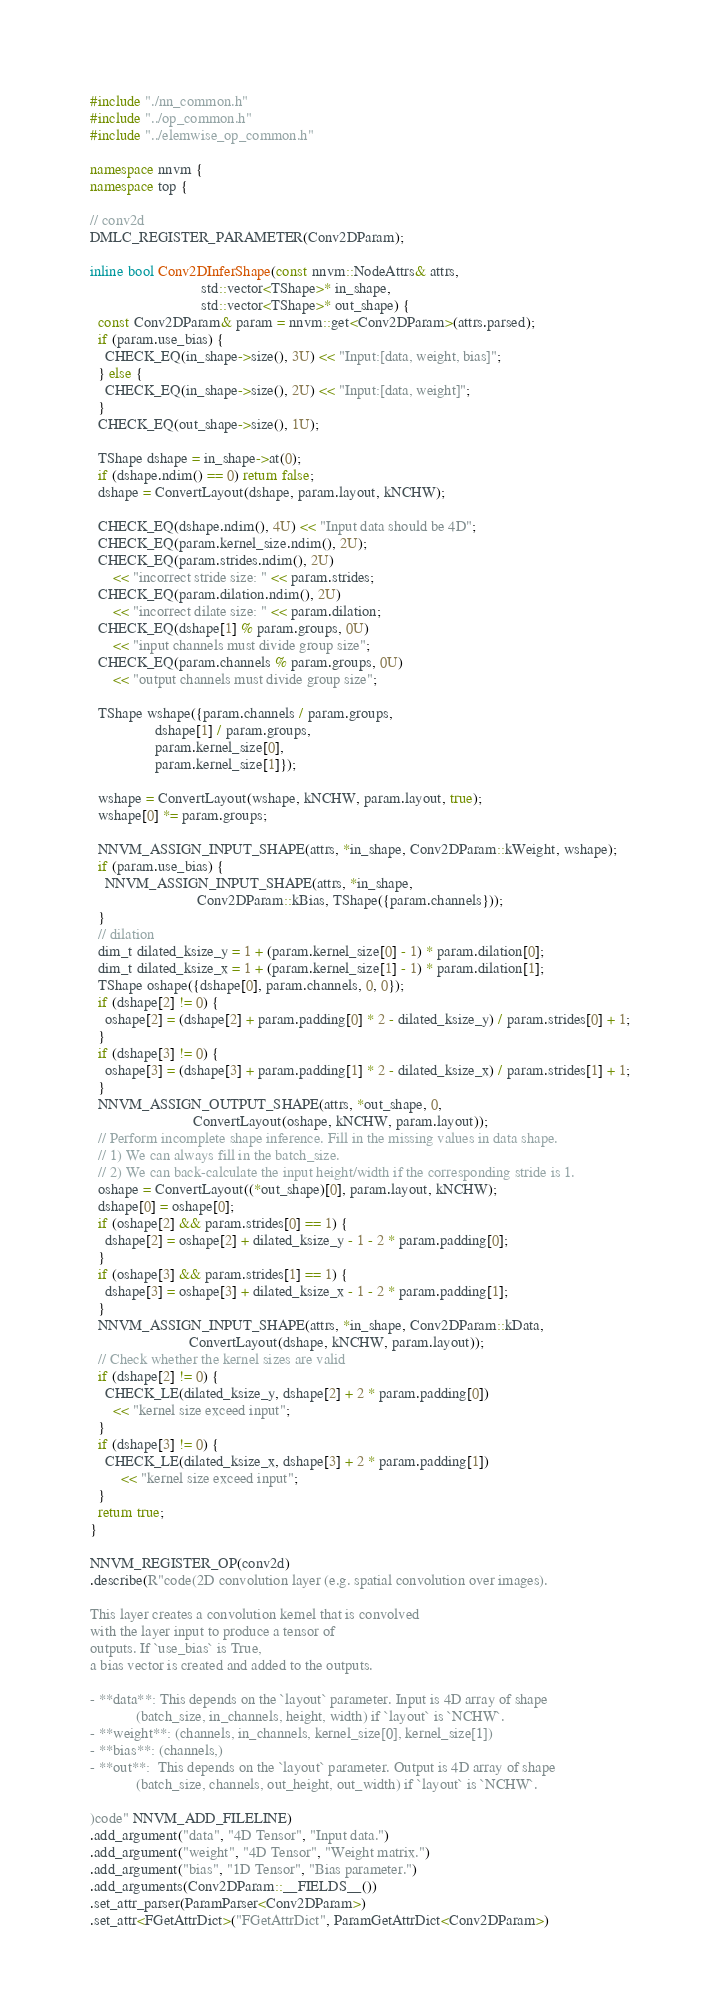Convert code to text. <code><loc_0><loc_0><loc_500><loc_500><_C++_>#include "./nn_common.h"
#include "../op_common.h"
#include "../elemwise_op_common.h"

namespace nnvm {
namespace top {

// conv2d
DMLC_REGISTER_PARAMETER(Conv2DParam);

inline bool Conv2DInferShape(const nnvm::NodeAttrs& attrs,
                             std::vector<TShape>* in_shape,
                             std::vector<TShape>* out_shape) {
  const Conv2DParam& param = nnvm::get<Conv2DParam>(attrs.parsed);
  if (param.use_bias) {
    CHECK_EQ(in_shape->size(), 3U) << "Input:[data, weight, bias]";
  } else {
    CHECK_EQ(in_shape->size(), 2U) << "Input:[data, weight]";
  }
  CHECK_EQ(out_shape->size(), 1U);

  TShape dshape = in_shape->at(0);
  if (dshape.ndim() == 0) return false;
  dshape = ConvertLayout(dshape, param.layout, kNCHW);

  CHECK_EQ(dshape.ndim(), 4U) << "Input data should be 4D";
  CHECK_EQ(param.kernel_size.ndim(), 2U);
  CHECK_EQ(param.strides.ndim(), 2U)
      << "incorrect stride size: " << param.strides;
  CHECK_EQ(param.dilation.ndim(), 2U)
      << "incorrect dilate size: " << param.dilation;
  CHECK_EQ(dshape[1] % param.groups, 0U)
      << "input channels must divide group size";
  CHECK_EQ(param.channels % param.groups, 0U)
      << "output channels must divide group size";

  TShape wshape({param.channels / param.groups,
                 dshape[1] / param.groups,
                 param.kernel_size[0],
                 param.kernel_size[1]});

  wshape = ConvertLayout(wshape, kNCHW, param.layout, true);
  wshape[0] *= param.groups;

  NNVM_ASSIGN_INPUT_SHAPE(attrs, *in_shape, Conv2DParam::kWeight, wshape);
  if (param.use_bias) {
    NNVM_ASSIGN_INPUT_SHAPE(attrs, *in_shape,
                            Conv2DParam::kBias, TShape({param.channels}));
  }
  // dilation
  dim_t dilated_ksize_y = 1 + (param.kernel_size[0] - 1) * param.dilation[0];
  dim_t dilated_ksize_x = 1 + (param.kernel_size[1] - 1) * param.dilation[1];
  TShape oshape({dshape[0], param.channels, 0, 0});
  if (dshape[2] != 0) {
    oshape[2] = (dshape[2] + param.padding[0] * 2 - dilated_ksize_y) / param.strides[0] + 1;
  }
  if (dshape[3] != 0) {
    oshape[3] = (dshape[3] + param.padding[1] * 2 - dilated_ksize_x) / param.strides[1] + 1;
  }
  NNVM_ASSIGN_OUTPUT_SHAPE(attrs, *out_shape, 0,
                           ConvertLayout(oshape, kNCHW, param.layout));
  // Perform incomplete shape inference. Fill in the missing values in data shape.
  // 1) We can always fill in the batch_size.
  // 2) We can back-calculate the input height/width if the corresponding stride is 1.
  oshape = ConvertLayout((*out_shape)[0], param.layout, kNCHW);
  dshape[0] = oshape[0];
  if (oshape[2] && param.strides[0] == 1) {
    dshape[2] = oshape[2] + dilated_ksize_y - 1 - 2 * param.padding[0];
  }
  if (oshape[3] && param.strides[1] == 1) {
    dshape[3] = oshape[3] + dilated_ksize_x - 1 - 2 * param.padding[1];
  }
  NNVM_ASSIGN_INPUT_SHAPE(attrs, *in_shape, Conv2DParam::kData,
                          ConvertLayout(dshape, kNCHW, param.layout));
  // Check whether the kernel sizes are valid
  if (dshape[2] != 0) {
    CHECK_LE(dilated_ksize_y, dshape[2] + 2 * param.padding[0])
      << "kernel size exceed input";
  }
  if (dshape[3] != 0) {
    CHECK_LE(dilated_ksize_x, dshape[3] + 2 * param.padding[1])
        << "kernel size exceed input";
  }
  return true;
}

NNVM_REGISTER_OP(conv2d)
.describe(R"code(2D convolution layer (e.g. spatial convolution over images).

This layer creates a convolution kernel that is convolved
with the layer input to produce a tensor of
outputs. If `use_bias` is True,
a bias vector is created and added to the outputs.

- **data**: This depends on the `layout` parameter. Input is 4D array of shape
            (batch_size, in_channels, height, width) if `layout` is `NCHW`.
- **weight**: (channels, in_channels, kernel_size[0], kernel_size[1])
- **bias**: (channels,)
- **out**:  This depends on the `layout` parameter. Output is 4D array of shape
            (batch_size, channels, out_height, out_width) if `layout` is `NCHW`.

)code" NNVM_ADD_FILELINE)
.add_argument("data", "4D Tensor", "Input data.")
.add_argument("weight", "4D Tensor", "Weight matrix.")
.add_argument("bias", "1D Tensor", "Bias parameter.")
.add_arguments(Conv2DParam::__FIELDS__())
.set_attr_parser(ParamParser<Conv2DParam>)
.set_attr<FGetAttrDict>("FGetAttrDict", ParamGetAttrDict<Conv2DParam>)</code> 